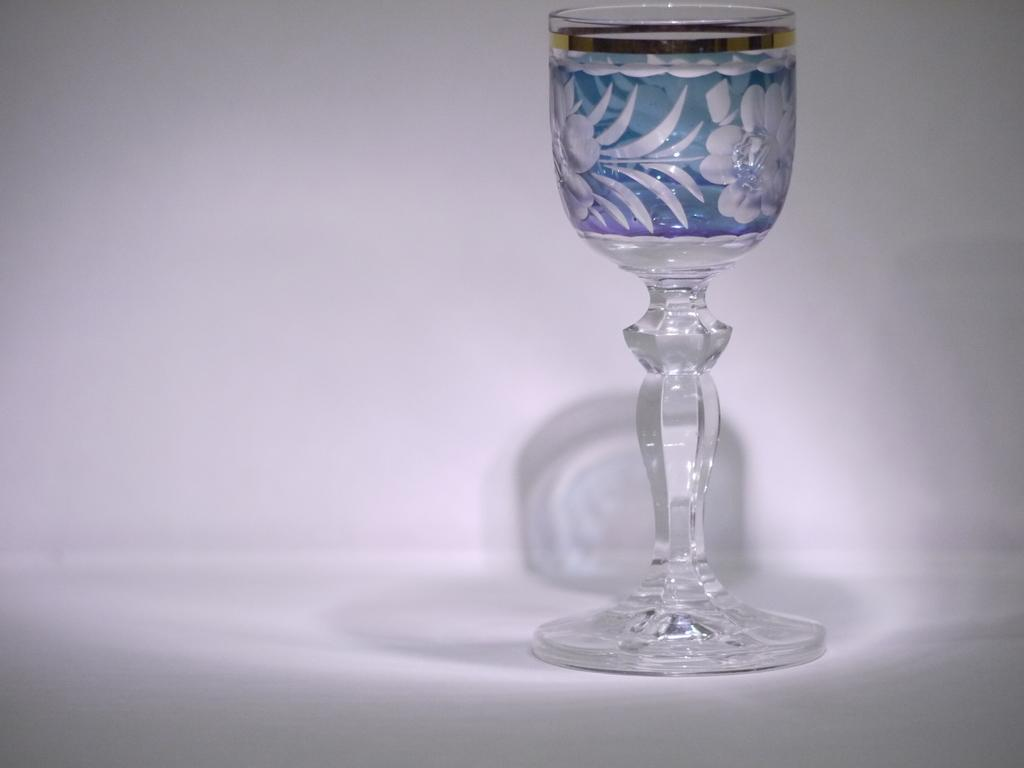What object with a design can be seen in the image? There is a glass with a design in the image. What color is the background of the image? The background of the image is white. Can you describe any additional features of the glass in the image? The shadow of the glass is visible on the background. Are there any toy plants visible in the image? There are no toy plants present in the image. What type of lift can be seen in the image? There is no lift present in the image. 